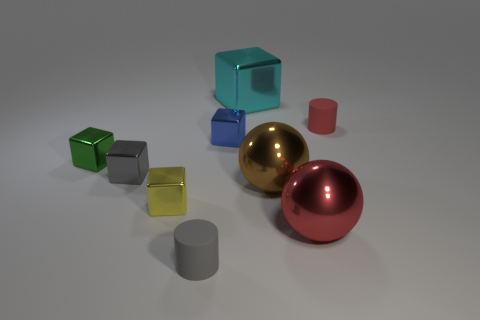Subtract all blue blocks. How many blocks are left? 4 Subtract all large metallic cubes. How many cubes are left? 4 Subtract all yellow blocks. Subtract all green spheres. How many blocks are left? 4 Add 1 rubber spheres. How many objects exist? 10 Subtract all cubes. How many objects are left? 4 Add 1 red balls. How many red balls are left? 2 Add 3 cyan blocks. How many cyan blocks exist? 4 Subtract 0 green balls. How many objects are left? 9 Subtract all red shiny objects. Subtract all small green metal things. How many objects are left? 7 